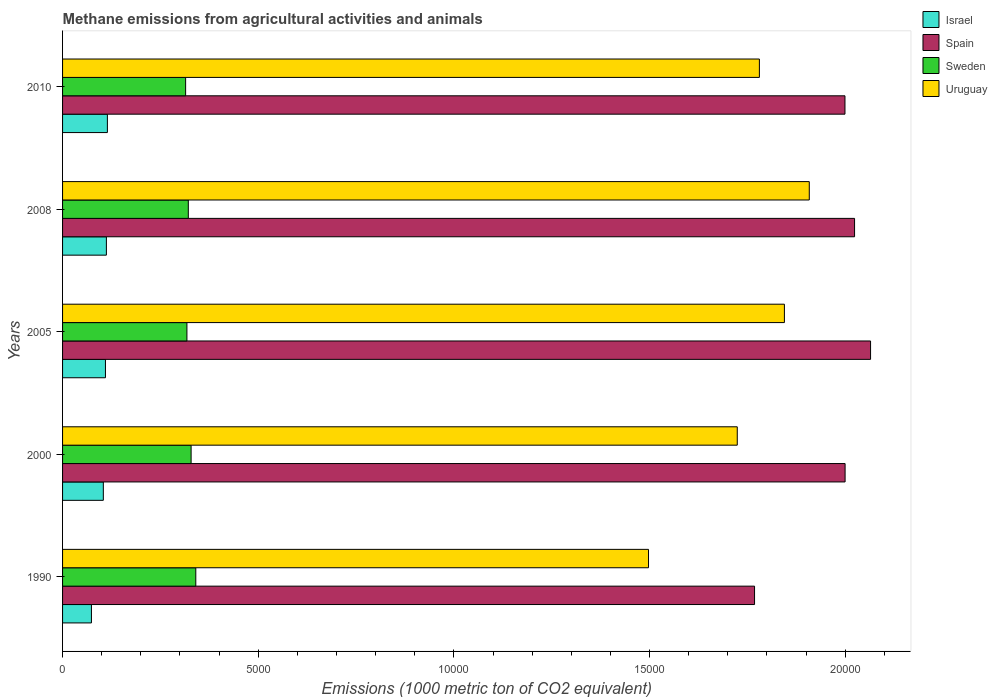How many different coloured bars are there?
Provide a short and direct response. 4. How many groups of bars are there?
Give a very brief answer. 5. Are the number of bars per tick equal to the number of legend labels?
Give a very brief answer. Yes. Are the number of bars on each tick of the Y-axis equal?
Your answer should be compact. Yes. How many bars are there on the 4th tick from the top?
Your answer should be compact. 4. What is the label of the 1st group of bars from the top?
Your answer should be compact. 2010. What is the amount of methane emitted in Israel in 2008?
Your answer should be very brief. 1119.7. Across all years, what is the maximum amount of methane emitted in Uruguay?
Give a very brief answer. 1.91e+04. Across all years, what is the minimum amount of methane emitted in Spain?
Offer a very short reply. 1.77e+04. In which year was the amount of methane emitted in Uruguay maximum?
Keep it short and to the point. 2008. What is the total amount of methane emitted in Spain in the graph?
Provide a succinct answer. 9.86e+04. What is the difference between the amount of methane emitted in Spain in 1990 and that in 2005?
Offer a very short reply. -2964.8. What is the difference between the amount of methane emitted in Spain in 2000 and the amount of methane emitted in Uruguay in 2008?
Your answer should be compact. 915.2. What is the average amount of methane emitted in Sweden per year?
Keep it short and to the point. 3244.94. In the year 2005, what is the difference between the amount of methane emitted in Sweden and amount of methane emitted in Israel?
Your answer should be very brief. 2081.7. What is the ratio of the amount of methane emitted in Spain in 2000 to that in 2008?
Your answer should be very brief. 0.99. Is the amount of methane emitted in Uruguay in 1990 less than that in 2008?
Keep it short and to the point. Yes. What is the difference between the highest and the second highest amount of methane emitted in Sweden?
Your answer should be compact. 119.8. What is the difference between the highest and the lowest amount of methane emitted in Spain?
Offer a terse response. 2964.8. In how many years, is the amount of methane emitted in Sweden greater than the average amount of methane emitted in Sweden taken over all years?
Your response must be concise. 2. Is it the case that in every year, the sum of the amount of methane emitted in Sweden and amount of methane emitted in Israel is greater than the sum of amount of methane emitted in Spain and amount of methane emitted in Uruguay?
Provide a short and direct response. Yes. Is it the case that in every year, the sum of the amount of methane emitted in Uruguay and amount of methane emitted in Sweden is greater than the amount of methane emitted in Spain?
Make the answer very short. Yes. Are all the bars in the graph horizontal?
Offer a terse response. Yes. How many years are there in the graph?
Ensure brevity in your answer.  5. What is the difference between two consecutive major ticks on the X-axis?
Keep it short and to the point. 5000. Are the values on the major ticks of X-axis written in scientific E-notation?
Offer a terse response. No. Where does the legend appear in the graph?
Your answer should be compact. Top right. How are the legend labels stacked?
Your answer should be compact. Vertical. What is the title of the graph?
Provide a short and direct response. Methane emissions from agricultural activities and animals. What is the label or title of the X-axis?
Your answer should be compact. Emissions (1000 metric ton of CO2 equivalent). What is the label or title of the Y-axis?
Offer a very short reply. Years. What is the Emissions (1000 metric ton of CO2 equivalent) in Israel in 1990?
Make the answer very short. 737.7. What is the Emissions (1000 metric ton of CO2 equivalent) in Spain in 1990?
Offer a terse response. 1.77e+04. What is the Emissions (1000 metric ton of CO2 equivalent) in Sweden in 1990?
Ensure brevity in your answer.  3404.5. What is the Emissions (1000 metric ton of CO2 equivalent) of Uruguay in 1990?
Make the answer very short. 1.50e+04. What is the Emissions (1000 metric ton of CO2 equivalent) in Israel in 2000?
Keep it short and to the point. 1041.6. What is the Emissions (1000 metric ton of CO2 equivalent) in Spain in 2000?
Your response must be concise. 2.00e+04. What is the Emissions (1000 metric ton of CO2 equivalent) of Sweden in 2000?
Your response must be concise. 3284.7. What is the Emissions (1000 metric ton of CO2 equivalent) of Uruguay in 2000?
Your response must be concise. 1.72e+04. What is the Emissions (1000 metric ton of CO2 equivalent) of Israel in 2005?
Ensure brevity in your answer.  1095.9. What is the Emissions (1000 metric ton of CO2 equivalent) of Spain in 2005?
Offer a very short reply. 2.06e+04. What is the Emissions (1000 metric ton of CO2 equivalent) of Sweden in 2005?
Ensure brevity in your answer.  3177.6. What is the Emissions (1000 metric ton of CO2 equivalent) in Uruguay in 2005?
Keep it short and to the point. 1.84e+04. What is the Emissions (1000 metric ton of CO2 equivalent) in Israel in 2008?
Provide a short and direct response. 1119.7. What is the Emissions (1000 metric ton of CO2 equivalent) in Spain in 2008?
Keep it short and to the point. 2.02e+04. What is the Emissions (1000 metric ton of CO2 equivalent) in Sweden in 2008?
Offer a very short reply. 3213.3. What is the Emissions (1000 metric ton of CO2 equivalent) in Uruguay in 2008?
Make the answer very short. 1.91e+04. What is the Emissions (1000 metric ton of CO2 equivalent) of Israel in 2010?
Give a very brief answer. 1145.5. What is the Emissions (1000 metric ton of CO2 equivalent) of Spain in 2010?
Offer a terse response. 2.00e+04. What is the Emissions (1000 metric ton of CO2 equivalent) in Sweden in 2010?
Your answer should be very brief. 3144.6. What is the Emissions (1000 metric ton of CO2 equivalent) of Uruguay in 2010?
Your answer should be very brief. 1.78e+04. Across all years, what is the maximum Emissions (1000 metric ton of CO2 equivalent) in Israel?
Give a very brief answer. 1145.5. Across all years, what is the maximum Emissions (1000 metric ton of CO2 equivalent) of Spain?
Your response must be concise. 2.06e+04. Across all years, what is the maximum Emissions (1000 metric ton of CO2 equivalent) in Sweden?
Ensure brevity in your answer.  3404.5. Across all years, what is the maximum Emissions (1000 metric ton of CO2 equivalent) in Uruguay?
Your answer should be very brief. 1.91e+04. Across all years, what is the minimum Emissions (1000 metric ton of CO2 equivalent) of Israel?
Offer a very short reply. 737.7. Across all years, what is the minimum Emissions (1000 metric ton of CO2 equivalent) of Spain?
Keep it short and to the point. 1.77e+04. Across all years, what is the minimum Emissions (1000 metric ton of CO2 equivalent) of Sweden?
Ensure brevity in your answer.  3144.6. Across all years, what is the minimum Emissions (1000 metric ton of CO2 equivalent) of Uruguay?
Provide a short and direct response. 1.50e+04. What is the total Emissions (1000 metric ton of CO2 equivalent) of Israel in the graph?
Provide a short and direct response. 5140.4. What is the total Emissions (1000 metric ton of CO2 equivalent) in Spain in the graph?
Offer a very short reply. 9.86e+04. What is the total Emissions (1000 metric ton of CO2 equivalent) in Sweden in the graph?
Ensure brevity in your answer.  1.62e+04. What is the total Emissions (1000 metric ton of CO2 equivalent) in Uruguay in the graph?
Ensure brevity in your answer.  8.75e+04. What is the difference between the Emissions (1000 metric ton of CO2 equivalent) in Israel in 1990 and that in 2000?
Keep it short and to the point. -303.9. What is the difference between the Emissions (1000 metric ton of CO2 equivalent) of Spain in 1990 and that in 2000?
Provide a succinct answer. -2314.1. What is the difference between the Emissions (1000 metric ton of CO2 equivalent) of Sweden in 1990 and that in 2000?
Offer a very short reply. 119.8. What is the difference between the Emissions (1000 metric ton of CO2 equivalent) of Uruguay in 1990 and that in 2000?
Offer a very short reply. -2267.7. What is the difference between the Emissions (1000 metric ton of CO2 equivalent) in Israel in 1990 and that in 2005?
Make the answer very short. -358.2. What is the difference between the Emissions (1000 metric ton of CO2 equivalent) of Spain in 1990 and that in 2005?
Keep it short and to the point. -2964.8. What is the difference between the Emissions (1000 metric ton of CO2 equivalent) of Sweden in 1990 and that in 2005?
Ensure brevity in your answer.  226.9. What is the difference between the Emissions (1000 metric ton of CO2 equivalent) of Uruguay in 1990 and that in 2005?
Your response must be concise. -3472.5. What is the difference between the Emissions (1000 metric ton of CO2 equivalent) of Israel in 1990 and that in 2008?
Offer a terse response. -382. What is the difference between the Emissions (1000 metric ton of CO2 equivalent) in Spain in 1990 and that in 2008?
Offer a terse response. -2555.9. What is the difference between the Emissions (1000 metric ton of CO2 equivalent) in Sweden in 1990 and that in 2008?
Your answer should be very brief. 191.2. What is the difference between the Emissions (1000 metric ton of CO2 equivalent) of Uruguay in 1990 and that in 2008?
Keep it short and to the point. -4108.2. What is the difference between the Emissions (1000 metric ton of CO2 equivalent) of Israel in 1990 and that in 2010?
Your answer should be very brief. -407.8. What is the difference between the Emissions (1000 metric ton of CO2 equivalent) of Spain in 1990 and that in 2010?
Ensure brevity in your answer.  -2311. What is the difference between the Emissions (1000 metric ton of CO2 equivalent) in Sweden in 1990 and that in 2010?
Ensure brevity in your answer.  259.9. What is the difference between the Emissions (1000 metric ton of CO2 equivalent) of Uruguay in 1990 and that in 2010?
Ensure brevity in your answer.  -2833.1. What is the difference between the Emissions (1000 metric ton of CO2 equivalent) in Israel in 2000 and that in 2005?
Provide a succinct answer. -54.3. What is the difference between the Emissions (1000 metric ton of CO2 equivalent) in Spain in 2000 and that in 2005?
Offer a very short reply. -650.7. What is the difference between the Emissions (1000 metric ton of CO2 equivalent) of Sweden in 2000 and that in 2005?
Your answer should be compact. 107.1. What is the difference between the Emissions (1000 metric ton of CO2 equivalent) in Uruguay in 2000 and that in 2005?
Your answer should be compact. -1204.8. What is the difference between the Emissions (1000 metric ton of CO2 equivalent) of Israel in 2000 and that in 2008?
Your response must be concise. -78.1. What is the difference between the Emissions (1000 metric ton of CO2 equivalent) of Spain in 2000 and that in 2008?
Provide a succinct answer. -241.8. What is the difference between the Emissions (1000 metric ton of CO2 equivalent) of Sweden in 2000 and that in 2008?
Ensure brevity in your answer.  71.4. What is the difference between the Emissions (1000 metric ton of CO2 equivalent) of Uruguay in 2000 and that in 2008?
Offer a very short reply. -1840.5. What is the difference between the Emissions (1000 metric ton of CO2 equivalent) in Israel in 2000 and that in 2010?
Offer a terse response. -103.9. What is the difference between the Emissions (1000 metric ton of CO2 equivalent) in Sweden in 2000 and that in 2010?
Your response must be concise. 140.1. What is the difference between the Emissions (1000 metric ton of CO2 equivalent) of Uruguay in 2000 and that in 2010?
Give a very brief answer. -565.4. What is the difference between the Emissions (1000 metric ton of CO2 equivalent) in Israel in 2005 and that in 2008?
Give a very brief answer. -23.8. What is the difference between the Emissions (1000 metric ton of CO2 equivalent) of Spain in 2005 and that in 2008?
Offer a terse response. 408.9. What is the difference between the Emissions (1000 metric ton of CO2 equivalent) in Sweden in 2005 and that in 2008?
Provide a short and direct response. -35.7. What is the difference between the Emissions (1000 metric ton of CO2 equivalent) of Uruguay in 2005 and that in 2008?
Your answer should be compact. -635.7. What is the difference between the Emissions (1000 metric ton of CO2 equivalent) in Israel in 2005 and that in 2010?
Ensure brevity in your answer.  -49.6. What is the difference between the Emissions (1000 metric ton of CO2 equivalent) of Spain in 2005 and that in 2010?
Give a very brief answer. 653.8. What is the difference between the Emissions (1000 metric ton of CO2 equivalent) of Uruguay in 2005 and that in 2010?
Make the answer very short. 639.4. What is the difference between the Emissions (1000 metric ton of CO2 equivalent) in Israel in 2008 and that in 2010?
Offer a very short reply. -25.8. What is the difference between the Emissions (1000 metric ton of CO2 equivalent) in Spain in 2008 and that in 2010?
Keep it short and to the point. 244.9. What is the difference between the Emissions (1000 metric ton of CO2 equivalent) in Sweden in 2008 and that in 2010?
Your answer should be compact. 68.7. What is the difference between the Emissions (1000 metric ton of CO2 equivalent) of Uruguay in 2008 and that in 2010?
Offer a terse response. 1275.1. What is the difference between the Emissions (1000 metric ton of CO2 equivalent) in Israel in 1990 and the Emissions (1000 metric ton of CO2 equivalent) in Spain in 2000?
Offer a terse response. -1.93e+04. What is the difference between the Emissions (1000 metric ton of CO2 equivalent) in Israel in 1990 and the Emissions (1000 metric ton of CO2 equivalent) in Sweden in 2000?
Provide a short and direct response. -2547. What is the difference between the Emissions (1000 metric ton of CO2 equivalent) in Israel in 1990 and the Emissions (1000 metric ton of CO2 equivalent) in Uruguay in 2000?
Keep it short and to the point. -1.65e+04. What is the difference between the Emissions (1000 metric ton of CO2 equivalent) in Spain in 1990 and the Emissions (1000 metric ton of CO2 equivalent) in Sweden in 2000?
Your answer should be very brief. 1.44e+04. What is the difference between the Emissions (1000 metric ton of CO2 equivalent) of Spain in 1990 and the Emissions (1000 metric ton of CO2 equivalent) of Uruguay in 2000?
Provide a succinct answer. 441.6. What is the difference between the Emissions (1000 metric ton of CO2 equivalent) in Sweden in 1990 and the Emissions (1000 metric ton of CO2 equivalent) in Uruguay in 2000?
Your response must be concise. -1.38e+04. What is the difference between the Emissions (1000 metric ton of CO2 equivalent) of Israel in 1990 and the Emissions (1000 metric ton of CO2 equivalent) of Spain in 2005?
Your answer should be compact. -1.99e+04. What is the difference between the Emissions (1000 metric ton of CO2 equivalent) of Israel in 1990 and the Emissions (1000 metric ton of CO2 equivalent) of Sweden in 2005?
Offer a very short reply. -2439.9. What is the difference between the Emissions (1000 metric ton of CO2 equivalent) in Israel in 1990 and the Emissions (1000 metric ton of CO2 equivalent) in Uruguay in 2005?
Provide a short and direct response. -1.77e+04. What is the difference between the Emissions (1000 metric ton of CO2 equivalent) in Spain in 1990 and the Emissions (1000 metric ton of CO2 equivalent) in Sweden in 2005?
Provide a short and direct response. 1.45e+04. What is the difference between the Emissions (1000 metric ton of CO2 equivalent) of Spain in 1990 and the Emissions (1000 metric ton of CO2 equivalent) of Uruguay in 2005?
Provide a short and direct response. -763.2. What is the difference between the Emissions (1000 metric ton of CO2 equivalent) of Sweden in 1990 and the Emissions (1000 metric ton of CO2 equivalent) of Uruguay in 2005?
Your response must be concise. -1.50e+04. What is the difference between the Emissions (1000 metric ton of CO2 equivalent) of Israel in 1990 and the Emissions (1000 metric ton of CO2 equivalent) of Spain in 2008?
Your response must be concise. -1.95e+04. What is the difference between the Emissions (1000 metric ton of CO2 equivalent) of Israel in 1990 and the Emissions (1000 metric ton of CO2 equivalent) of Sweden in 2008?
Your answer should be very brief. -2475.6. What is the difference between the Emissions (1000 metric ton of CO2 equivalent) of Israel in 1990 and the Emissions (1000 metric ton of CO2 equivalent) of Uruguay in 2008?
Make the answer very short. -1.83e+04. What is the difference between the Emissions (1000 metric ton of CO2 equivalent) in Spain in 1990 and the Emissions (1000 metric ton of CO2 equivalent) in Sweden in 2008?
Give a very brief answer. 1.45e+04. What is the difference between the Emissions (1000 metric ton of CO2 equivalent) of Spain in 1990 and the Emissions (1000 metric ton of CO2 equivalent) of Uruguay in 2008?
Your answer should be compact. -1398.9. What is the difference between the Emissions (1000 metric ton of CO2 equivalent) in Sweden in 1990 and the Emissions (1000 metric ton of CO2 equivalent) in Uruguay in 2008?
Make the answer very short. -1.57e+04. What is the difference between the Emissions (1000 metric ton of CO2 equivalent) in Israel in 1990 and the Emissions (1000 metric ton of CO2 equivalent) in Spain in 2010?
Offer a terse response. -1.93e+04. What is the difference between the Emissions (1000 metric ton of CO2 equivalent) of Israel in 1990 and the Emissions (1000 metric ton of CO2 equivalent) of Sweden in 2010?
Offer a terse response. -2406.9. What is the difference between the Emissions (1000 metric ton of CO2 equivalent) in Israel in 1990 and the Emissions (1000 metric ton of CO2 equivalent) in Uruguay in 2010?
Your answer should be compact. -1.71e+04. What is the difference between the Emissions (1000 metric ton of CO2 equivalent) of Spain in 1990 and the Emissions (1000 metric ton of CO2 equivalent) of Sweden in 2010?
Give a very brief answer. 1.45e+04. What is the difference between the Emissions (1000 metric ton of CO2 equivalent) of Spain in 1990 and the Emissions (1000 metric ton of CO2 equivalent) of Uruguay in 2010?
Ensure brevity in your answer.  -123.8. What is the difference between the Emissions (1000 metric ton of CO2 equivalent) in Sweden in 1990 and the Emissions (1000 metric ton of CO2 equivalent) in Uruguay in 2010?
Offer a terse response. -1.44e+04. What is the difference between the Emissions (1000 metric ton of CO2 equivalent) in Israel in 2000 and the Emissions (1000 metric ton of CO2 equivalent) in Spain in 2005?
Make the answer very short. -1.96e+04. What is the difference between the Emissions (1000 metric ton of CO2 equivalent) of Israel in 2000 and the Emissions (1000 metric ton of CO2 equivalent) of Sweden in 2005?
Offer a very short reply. -2136. What is the difference between the Emissions (1000 metric ton of CO2 equivalent) in Israel in 2000 and the Emissions (1000 metric ton of CO2 equivalent) in Uruguay in 2005?
Your answer should be very brief. -1.74e+04. What is the difference between the Emissions (1000 metric ton of CO2 equivalent) in Spain in 2000 and the Emissions (1000 metric ton of CO2 equivalent) in Sweden in 2005?
Offer a very short reply. 1.68e+04. What is the difference between the Emissions (1000 metric ton of CO2 equivalent) in Spain in 2000 and the Emissions (1000 metric ton of CO2 equivalent) in Uruguay in 2005?
Offer a very short reply. 1550.9. What is the difference between the Emissions (1000 metric ton of CO2 equivalent) of Sweden in 2000 and the Emissions (1000 metric ton of CO2 equivalent) of Uruguay in 2005?
Ensure brevity in your answer.  -1.52e+04. What is the difference between the Emissions (1000 metric ton of CO2 equivalent) of Israel in 2000 and the Emissions (1000 metric ton of CO2 equivalent) of Spain in 2008?
Give a very brief answer. -1.92e+04. What is the difference between the Emissions (1000 metric ton of CO2 equivalent) of Israel in 2000 and the Emissions (1000 metric ton of CO2 equivalent) of Sweden in 2008?
Make the answer very short. -2171.7. What is the difference between the Emissions (1000 metric ton of CO2 equivalent) of Israel in 2000 and the Emissions (1000 metric ton of CO2 equivalent) of Uruguay in 2008?
Make the answer very short. -1.80e+04. What is the difference between the Emissions (1000 metric ton of CO2 equivalent) in Spain in 2000 and the Emissions (1000 metric ton of CO2 equivalent) in Sweden in 2008?
Provide a short and direct response. 1.68e+04. What is the difference between the Emissions (1000 metric ton of CO2 equivalent) in Spain in 2000 and the Emissions (1000 metric ton of CO2 equivalent) in Uruguay in 2008?
Your answer should be very brief. 915.2. What is the difference between the Emissions (1000 metric ton of CO2 equivalent) in Sweden in 2000 and the Emissions (1000 metric ton of CO2 equivalent) in Uruguay in 2008?
Your answer should be very brief. -1.58e+04. What is the difference between the Emissions (1000 metric ton of CO2 equivalent) of Israel in 2000 and the Emissions (1000 metric ton of CO2 equivalent) of Spain in 2010?
Keep it short and to the point. -1.90e+04. What is the difference between the Emissions (1000 metric ton of CO2 equivalent) in Israel in 2000 and the Emissions (1000 metric ton of CO2 equivalent) in Sweden in 2010?
Make the answer very short. -2103. What is the difference between the Emissions (1000 metric ton of CO2 equivalent) of Israel in 2000 and the Emissions (1000 metric ton of CO2 equivalent) of Uruguay in 2010?
Provide a short and direct response. -1.68e+04. What is the difference between the Emissions (1000 metric ton of CO2 equivalent) of Spain in 2000 and the Emissions (1000 metric ton of CO2 equivalent) of Sweden in 2010?
Provide a short and direct response. 1.69e+04. What is the difference between the Emissions (1000 metric ton of CO2 equivalent) in Spain in 2000 and the Emissions (1000 metric ton of CO2 equivalent) in Uruguay in 2010?
Your answer should be very brief. 2190.3. What is the difference between the Emissions (1000 metric ton of CO2 equivalent) in Sweden in 2000 and the Emissions (1000 metric ton of CO2 equivalent) in Uruguay in 2010?
Make the answer very short. -1.45e+04. What is the difference between the Emissions (1000 metric ton of CO2 equivalent) in Israel in 2005 and the Emissions (1000 metric ton of CO2 equivalent) in Spain in 2008?
Provide a succinct answer. -1.91e+04. What is the difference between the Emissions (1000 metric ton of CO2 equivalent) in Israel in 2005 and the Emissions (1000 metric ton of CO2 equivalent) in Sweden in 2008?
Provide a succinct answer. -2117.4. What is the difference between the Emissions (1000 metric ton of CO2 equivalent) of Israel in 2005 and the Emissions (1000 metric ton of CO2 equivalent) of Uruguay in 2008?
Give a very brief answer. -1.80e+04. What is the difference between the Emissions (1000 metric ton of CO2 equivalent) in Spain in 2005 and the Emissions (1000 metric ton of CO2 equivalent) in Sweden in 2008?
Provide a short and direct response. 1.74e+04. What is the difference between the Emissions (1000 metric ton of CO2 equivalent) in Spain in 2005 and the Emissions (1000 metric ton of CO2 equivalent) in Uruguay in 2008?
Your response must be concise. 1565.9. What is the difference between the Emissions (1000 metric ton of CO2 equivalent) of Sweden in 2005 and the Emissions (1000 metric ton of CO2 equivalent) of Uruguay in 2008?
Your answer should be compact. -1.59e+04. What is the difference between the Emissions (1000 metric ton of CO2 equivalent) in Israel in 2005 and the Emissions (1000 metric ton of CO2 equivalent) in Spain in 2010?
Keep it short and to the point. -1.89e+04. What is the difference between the Emissions (1000 metric ton of CO2 equivalent) in Israel in 2005 and the Emissions (1000 metric ton of CO2 equivalent) in Sweden in 2010?
Provide a short and direct response. -2048.7. What is the difference between the Emissions (1000 metric ton of CO2 equivalent) in Israel in 2005 and the Emissions (1000 metric ton of CO2 equivalent) in Uruguay in 2010?
Your answer should be very brief. -1.67e+04. What is the difference between the Emissions (1000 metric ton of CO2 equivalent) of Spain in 2005 and the Emissions (1000 metric ton of CO2 equivalent) of Sweden in 2010?
Your answer should be very brief. 1.75e+04. What is the difference between the Emissions (1000 metric ton of CO2 equivalent) in Spain in 2005 and the Emissions (1000 metric ton of CO2 equivalent) in Uruguay in 2010?
Make the answer very short. 2841. What is the difference between the Emissions (1000 metric ton of CO2 equivalent) of Sweden in 2005 and the Emissions (1000 metric ton of CO2 equivalent) of Uruguay in 2010?
Your response must be concise. -1.46e+04. What is the difference between the Emissions (1000 metric ton of CO2 equivalent) in Israel in 2008 and the Emissions (1000 metric ton of CO2 equivalent) in Spain in 2010?
Keep it short and to the point. -1.89e+04. What is the difference between the Emissions (1000 metric ton of CO2 equivalent) in Israel in 2008 and the Emissions (1000 metric ton of CO2 equivalent) in Sweden in 2010?
Offer a terse response. -2024.9. What is the difference between the Emissions (1000 metric ton of CO2 equivalent) of Israel in 2008 and the Emissions (1000 metric ton of CO2 equivalent) of Uruguay in 2010?
Your response must be concise. -1.67e+04. What is the difference between the Emissions (1000 metric ton of CO2 equivalent) in Spain in 2008 and the Emissions (1000 metric ton of CO2 equivalent) in Sweden in 2010?
Provide a succinct answer. 1.71e+04. What is the difference between the Emissions (1000 metric ton of CO2 equivalent) in Spain in 2008 and the Emissions (1000 metric ton of CO2 equivalent) in Uruguay in 2010?
Make the answer very short. 2432.1. What is the difference between the Emissions (1000 metric ton of CO2 equivalent) in Sweden in 2008 and the Emissions (1000 metric ton of CO2 equivalent) in Uruguay in 2010?
Provide a short and direct response. -1.46e+04. What is the average Emissions (1000 metric ton of CO2 equivalent) of Israel per year?
Your answer should be very brief. 1028.08. What is the average Emissions (1000 metric ton of CO2 equivalent) of Spain per year?
Provide a short and direct response. 1.97e+04. What is the average Emissions (1000 metric ton of CO2 equivalent) of Sweden per year?
Offer a very short reply. 3244.94. What is the average Emissions (1000 metric ton of CO2 equivalent) in Uruguay per year?
Provide a short and direct response. 1.75e+04. In the year 1990, what is the difference between the Emissions (1000 metric ton of CO2 equivalent) in Israel and Emissions (1000 metric ton of CO2 equivalent) in Spain?
Your answer should be compact. -1.69e+04. In the year 1990, what is the difference between the Emissions (1000 metric ton of CO2 equivalent) of Israel and Emissions (1000 metric ton of CO2 equivalent) of Sweden?
Offer a very short reply. -2666.8. In the year 1990, what is the difference between the Emissions (1000 metric ton of CO2 equivalent) of Israel and Emissions (1000 metric ton of CO2 equivalent) of Uruguay?
Ensure brevity in your answer.  -1.42e+04. In the year 1990, what is the difference between the Emissions (1000 metric ton of CO2 equivalent) in Spain and Emissions (1000 metric ton of CO2 equivalent) in Sweden?
Provide a short and direct response. 1.43e+04. In the year 1990, what is the difference between the Emissions (1000 metric ton of CO2 equivalent) of Spain and Emissions (1000 metric ton of CO2 equivalent) of Uruguay?
Offer a terse response. 2709.3. In the year 1990, what is the difference between the Emissions (1000 metric ton of CO2 equivalent) of Sweden and Emissions (1000 metric ton of CO2 equivalent) of Uruguay?
Give a very brief answer. -1.16e+04. In the year 2000, what is the difference between the Emissions (1000 metric ton of CO2 equivalent) in Israel and Emissions (1000 metric ton of CO2 equivalent) in Spain?
Provide a succinct answer. -1.90e+04. In the year 2000, what is the difference between the Emissions (1000 metric ton of CO2 equivalent) in Israel and Emissions (1000 metric ton of CO2 equivalent) in Sweden?
Your answer should be very brief. -2243.1. In the year 2000, what is the difference between the Emissions (1000 metric ton of CO2 equivalent) of Israel and Emissions (1000 metric ton of CO2 equivalent) of Uruguay?
Give a very brief answer. -1.62e+04. In the year 2000, what is the difference between the Emissions (1000 metric ton of CO2 equivalent) of Spain and Emissions (1000 metric ton of CO2 equivalent) of Sweden?
Your answer should be very brief. 1.67e+04. In the year 2000, what is the difference between the Emissions (1000 metric ton of CO2 equivalent) of Spain and Emissions (1000 metric ton of CO2 equivalent) of Uruguay?
Give a very brief answer. 2755.7. In the year 2000, what is the difference between the Emissions (1000 metric ton of CO2 equivalent) in Sweden and Emissions (1000 metric ton of CO2 equivalent) in Uruguay?
Provide a short and direct response. -1.40e+04. In the year 2005, what is the difference between the Emissions (1000 metric ton of CO2 equivalent) of Israel and Emissions (1000 metric ton of CO2 equivalent) of Spain?
Your answer should be very brief. -1.96e+04. In the year 2005, what is the difference between the Emissions (1000 metric ton of CO2 equivalent) in Israel and Emissions (1000 metric ton of CO2 equivalent) in Sweden?
Provide a succinct answer. -2081.7. In the year 2005, what is the difference between the Emissions (1000 metric ton of CO2 equivalent) of Israel and Emissions (1000 metric ton of CO2 equivalent) of Uruguay?
Your answer should be compact. -1.73e+04. In the year 2005, what is the difference between the Emissions (1000 metric ton of CO2 equivalent) in Spain and Emissions (1000 metric ton of CO2 equivalent) in Sweden?
Your answer should be very brief. 1.75e+04. In the year 2005, what is the difference between the Emissions (1000 metric ton of CO2 equivalent) of Spain and Emissions (1000 metric ton of CO2 equivalent) of Uruguay?
Your answer should be very brief. 2201.6. In the year 2005, what is the difference between the Emissions (1000 metric ton of CO2 equivalent) in Sweden and Emissions (1000 metric ton of CO2 equivalent) in Uruguay?
Offer a terse response. -1.53e+04. In the year 2008, what is the difference between the Emissions (1000 metric ton of CO2 equivalent) of Israel and Emissions (1000 metric ton of CO2 equivalent) of Spain?
Keep it short and to the point. -1.91e+04. In the year 2008, what is the difference between the Emissions (1000 metric ton of CO2 equivalent) in Israel and Emissions (1000 metric ton of CO2 equivalent) in Sweden?
Give a very brief answer. -2093.6. In the year 2008, what is the difference between the Emissions (1000 metric ton of CO2 equivalent) in Israel and Emissions (1000 metric ton of CO2 equivalent) in Uruguay?
Your answer should be compact. -1.80e+04. In the year 2008, what is the difference between the Emissions (1000 metric ton of CO2 equivalent) in Spain and Emissions (1000 metric ton of CO2 equivalent) in Sweden?
Your answer should be very brief. 1.70e+04. In the year 2008, what is the difference between the Emissions (1000 metric ton of CO2 equivalent) of Spain and Emissions (1000 metric ton of CO2 equivalent) of Uruguay?
Offer a terse response. 1157. In the year 2008, what is the difference between the Emissions (1000 metric ton of CO2 equivalent) of Sweden and Emissions (1000 metric ton of CO2 equivalent) of Uruguay?
Offer a very short reply. -1.59e+04. In the year 2010, what is the difference between the Emissions (1000 metric ton of CO2 equivalent) of Israel and Emissions (1000 metric ton of CO2 equivalent) of Spain?
Your answer should be very brief. -1.88e+04. In the year 2010, what is the difference between the Emissions (1000 metric ton of CO2 equivalent) in Israel and Emissions (1000 metric ton of CO2 equivalent) in Sweden?
Your answer should be compact. -1999.1. In the year 2010, what is the difference between the Emissions (1000 metric ton of CO2 equivalent) of Israel and Emissions (1000 metric ton of CO2 equivalent) of Uruguay?
Your answer should be compact. -1.67e+04. In the year 2010, what is the difference between the Emissions (1000 metric ton of CO2 equivalent) of Spain and Emissions (1000 metric ton of CO2 equivalent) of Sweden?
Provide a succinct answer. 1.68e+04. In the year 2010, what is the difference between the Emissions (1000 metric ton of CO2 equivalent) in Spain and Emissions (1000 metric ton of CO2 equivalent) in Uruguay?
Provide a short and direct response. 2187.2. In the year 2010, what is the difference between the Emissions (1000 metric ton of CO2 equivalent) of Sweden and Emissions (1000 metric ton of CO2 equivalent) of Uruguay?
Your answer should be very brief. -1.47e+04. What is the ratio of the Emissions (1000 metric ton of CO2 equivalent) in Israel in 1990 to that in 2000?
Your response must be concise. 0.71. What is the ratio of the Emissions (1000 metric ton of CO2 equivalent) in Spain in 1990 to that in 2000?
Offer a very short reply. 0.88. What is the ratio of the Emissions (1000 metric ton of CO2 equivalent) in Sweden in 1990 to that in 2000?
Your answer should be compact. 1.04. What is the ratio of the Emissions (1000 metric ton of CO2 equivalent) of Uruguay in 1990 to that in 2000?
Your response must be concise. 0.87. What is the ratio of the Emissions (1000 metric ton of CO2 equivalent) in Israel in 1990 to that in 2005?
Provide a succinct answer. 0.67. What is the ratio of the Emissions (1000 metric ton of CO2 equivalent) in Spain in 1990 to that in 2005?
Provide a short and direct response. 0.86. What is the ratio of the Emissions (1000 metric ton of CO2 equivalent) in Sweden in 1990 to that in 2005?
Make the answer very short. 1.07. What is the ratio of the Emissions (1000 metric ton of CO2 equivalent) in Uruguay in 1990 to that in 2005?
Your answer should be very brief. 0.81. What is the ratio of the Emissions (1000 metric ton of CO2 equivalent) in Israel in 1990 to that in 2008?
Ensure brevity in your answer.  0.66. What is the ratio of the Emissions (1000 metric ton of CO2 equivalent) in Spain in 1990 to that in 2008?
Your answer should be very brief. 0.87. What is the ratio of the Emissions (1000 metric ton of CO2 equivalent) in Sweden in 1990 to that in 2008?
Your answer should be very brief. 1.06. What is the ratio of the Emissions (1000 metric ton of CO2 equivalent) in Uruguay in 1990 to that in 2008?
Give a very brief answer. 0.78. What is the ratio of the Emissions (1000 metric ton of CO2 equivalent) of Israel in 1990 to that in 2010?
Make the answer very short. 0.64. What is the ratio of the Emissions (1000 metric ton of CO2 equivalent) of Spain in 1990 to that in 2010?
Make the answer very short. 0.88. What is the ratio of the Emissions (1000 metric ton of CO2 equivalent) of Sweden in 1990 to that in 2010?
Your answer should be compact. 1.08. What is the ratio of the Emissions (1000 metric ton of CO2 equivalent) of Uruguay in 1990 to that in 2010?
Your response must be concise. 0.84. What is the ratio of the Emissions (1000 metric ton of CO2 equivalent) in Israel in 2000 to that in 2005?
Keep it short and to the point. 0.95. What is the ratio of the Emissions (1000 metric ton of CO2 equivalent) in Spain in 2000 to that in 2005?
Offer a terse response. 0.97. What is the ratio of the Emissions (1000 metric ton of CO2 equivalent) of Sweden in 2000 to that in 2005?
Provide a succinct answer. 1.03. What is the ratio of the Emissions (1000 metric ton of CO2 equivalent) in Uruguay in 2000 to that in 2005?
Offer a terse response. 0.93. What is the ratio of the Emissions (1000 metric ton of CO2 equivalent) in Israel in 2000 to that in 2008?
Give a very brief answer. 0.93. What is the ratio of the Emissions (1000 metric ton of CO2 equivalent) in Sweden in 2000 to that in 2008?
Ensure brevity in your answer.  1.02. What is the ratio of the Emissions (1000 metric ton of CO2 equivalent) of Uruguay in 2000 to that in 2008?
Ensure brevity in your answer.  0.9. What is the ratio of the Emissions (1000 metric ton of CO2 equivalent) in Israel in 2000 to that in 2010?
Your answer should be very brief. 0.91. What is the ratio of the Emissions (1000 metric ton of CO2 equivalent) in Spain in 2000 to that in 2010?
Your answer should be very brief. 1. What is the ratio of the Emissions (1000 metric ton of CO2 equivalent) of Sweden in 2000 to that in 2010?
Your response must be concise. 1.04. What is the ratio of the Emissions (1000 metric ton of CO2 equivalent) of Uruguay in 2000 to that in 2010?
Ensure brevity in your answer.  0.97. What is the ratio of the Emissions (1000 metric ton of CO2 equivalent) of Israel in 2005 to that in 2008?
Offer a terse response. 0.98. What is the ratio of the Emissions (1000 metric ton of CO2 equivalent) of Spain in 2005 to that in 2008?
Make the answer very short. 1.02. What is the ratio of the Emissions (1000 metric ton of CO2 equivalent) of Sweden in 2005 to that in 2008?
Your response must be concise. 0.99. What is the ratio of the Emissions (1000 metric ton of CO2 equivalent) in Uruguay in 2005 to that in 2008?
Ensure brevity in your answer.  0.97. What is the ratio of the Emissions (1000 metric ton of CO2 equivalent) in Israel in 2005 to that in 2010?
Offer a very short reply. 0.96. What is the ratio of the Emissions (1000 metric ton of CO2 equivalent) in Spain in 2005 to that in 2010?
Ensure brevity in your answer.  1.03. What is the ratio of the Emissions (1000 metric ton of CO2 equivalent) of Sweden in 2005 to that in 2010?
Give a very brief answer. 1.01. What is the ratio of the Emissions (1000 metric ton of CO2 equivalent) of Uruguay in 2005 to that in 2010?
Your answer should be very brief. 1.04. What is the ratio of the Emissions (1000 metric ton of CO2 equivalent) of Israel in 2008 to that in 2010?
Make the answer very short. 0.98. What is the ratio of the Emissions (1000 metric ton of CO2 equivalent) in Spain in 2008 to that in 2010?
Make the answer very short. 1.01. What is the ratio of the Emissions (1000 metric ton of CO2 equivalent) in Sweden in 2008 to that in 2010?
Offer a terse response. 1.02. What is the ratio of the Emissions (1000 metric ton of CO2 equivalent) of Uruguay in 2008 to that in 2010?
Provide a succinct answer. 1.07. What is the difference between the highest and the second highest Emissions (1000 metric ton of CO2 equivalent) of Israel?
Your answer should be very brief. 25.8. What is the difference between the highest and the second highest Emissions (1000 metric ton of CO2 equivalent) of Spain?
Keep it short and to the point. 408.9. What is the difference between the highest and the second highest Emissions (1000 metric ton of CO2 equivalent) of Sweden?
Your answer should be compact. 119.8. What is the difference between the highest and the second highest Emissions (1000 metric ton of CO2 equivalent) in Uruguay?
Offer a very short reply. 635.7. What is the difference between the highest and the lowest Emissions (1000 metric ton of CO2 equivalent) in Israel?
Offer a very short reply. 407.8. What is the difference between the highest and the lowest Emissions (1000 metric ton of CO2 equivalent) in Spain?
Provide a short and direct response. 2964.8. What is the difference between the highest and the lowest Emissions (1000 metric ton of CO2 equivalent) in Sweden?
Your answer should be compact. 259.9. What is the difference between the highest and the lowest Emissions (1000 metric ton of CO2 equivalent) in Uruguay?
Your response must be concise. 4108.2. 